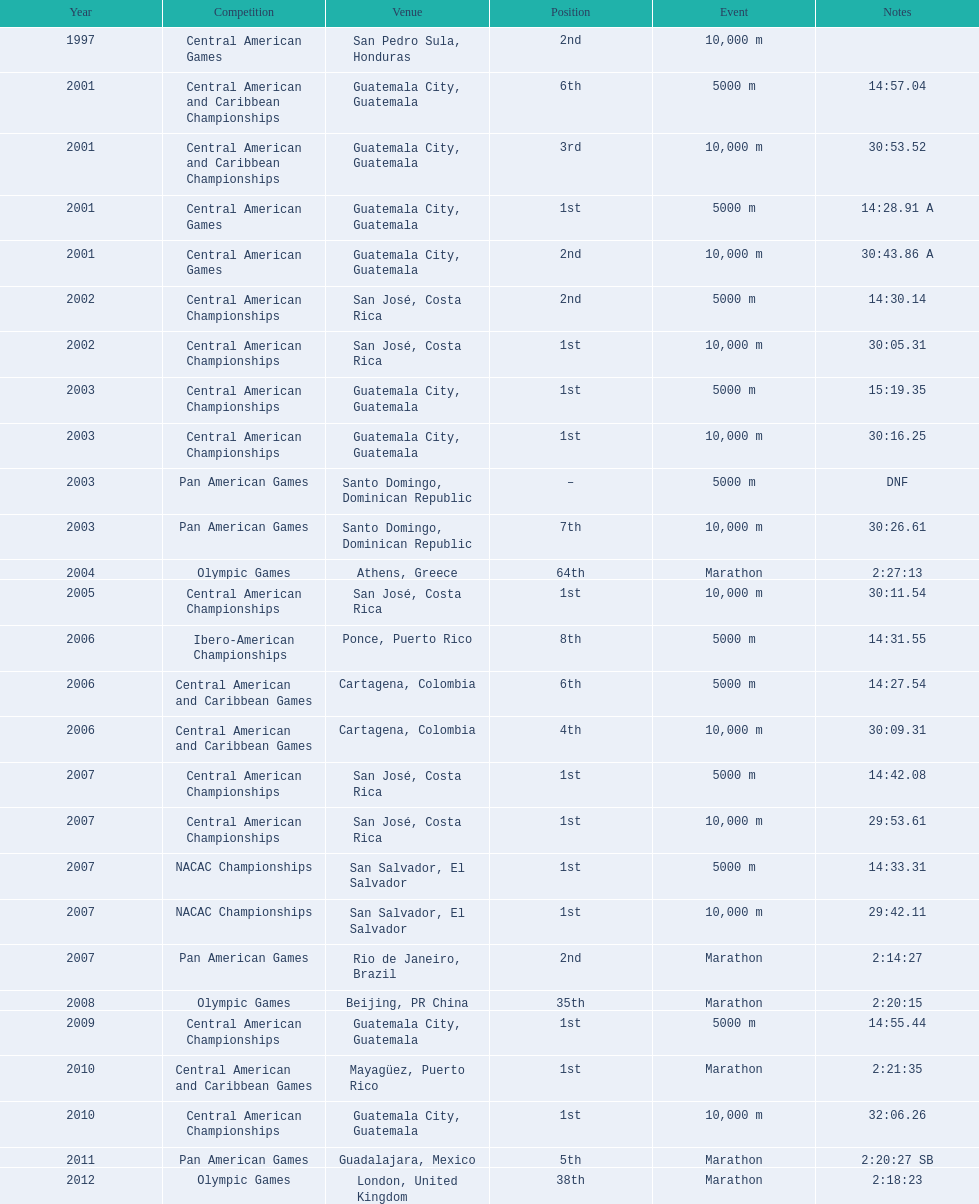How many times has the top position been accomplished? 12. 